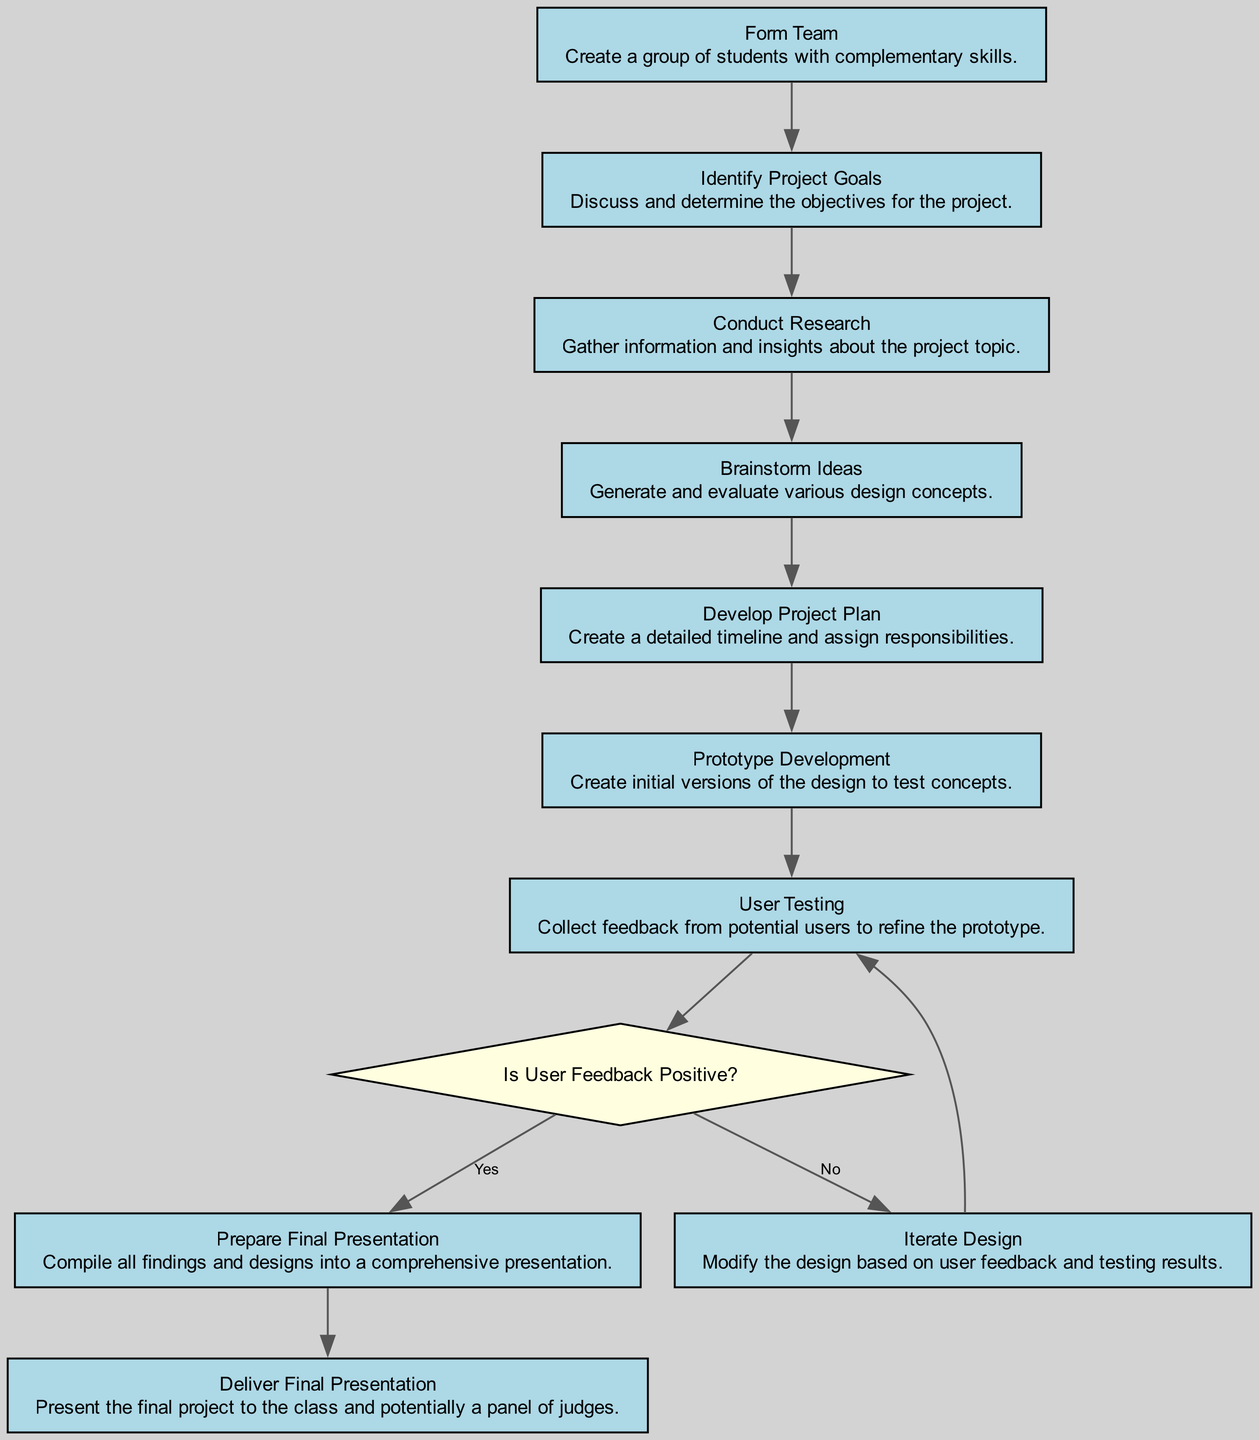What is the first activity in the diagram? The first activity is "Form Team." It is the starting point of the project workflow as indicated in the diagram, where students come together to create a group.
Answer: Form Team How many activities are there in total? The diagram lists 10 activities. Each activity contributes to the overall collaborative project management process.
Answer: 10 What follows after "Conduct Research"? After "Conduct Research," the next activity is "Brainstorm Ideas," as shown in the flow sequence connecting these two nodes.
Answer: Brainstorm Ideas What is the condition for moving from "User Testing" to "Prepare Final Presentation"? The condition is "Yes," indicating that user feedback must be positive to proceed to the preparation of the final presentation.
Answer: Yes What happens if the user feedback is not positive? If the user feedback is not positive, the flow directs the process back to "Iterate Design" for modifications before retesting the prototype.
Answer: Iterate Design Which activity comes before "Prototype Development"? The activity that comes before "Prototype Development" is "Develop Project Plan." This is a prerequisite to create the prototypes, as planning the project is essential at this stage.
Answer: Develop Project Plan What type of node is "Is User Feedback Positive?" The node "Is User Feedback Positive?" is a decision node, represented by a diamond shape in the diagram, indicating a point where the flow can diverge based on feedback.
Answer: Decision node How many decision points are in the diagram? There is 1 decision point represented in the diagram, which is "Is User Feedback Positive?" This is the only decision that impacts the subsequent flow.
Answer: 1 What is the last activity in the diagram? The last activity in the diagram is "Deliver Final Presentation," which occurs after the preparation of the final presentation.
Answer: Deliver Final Presentation 